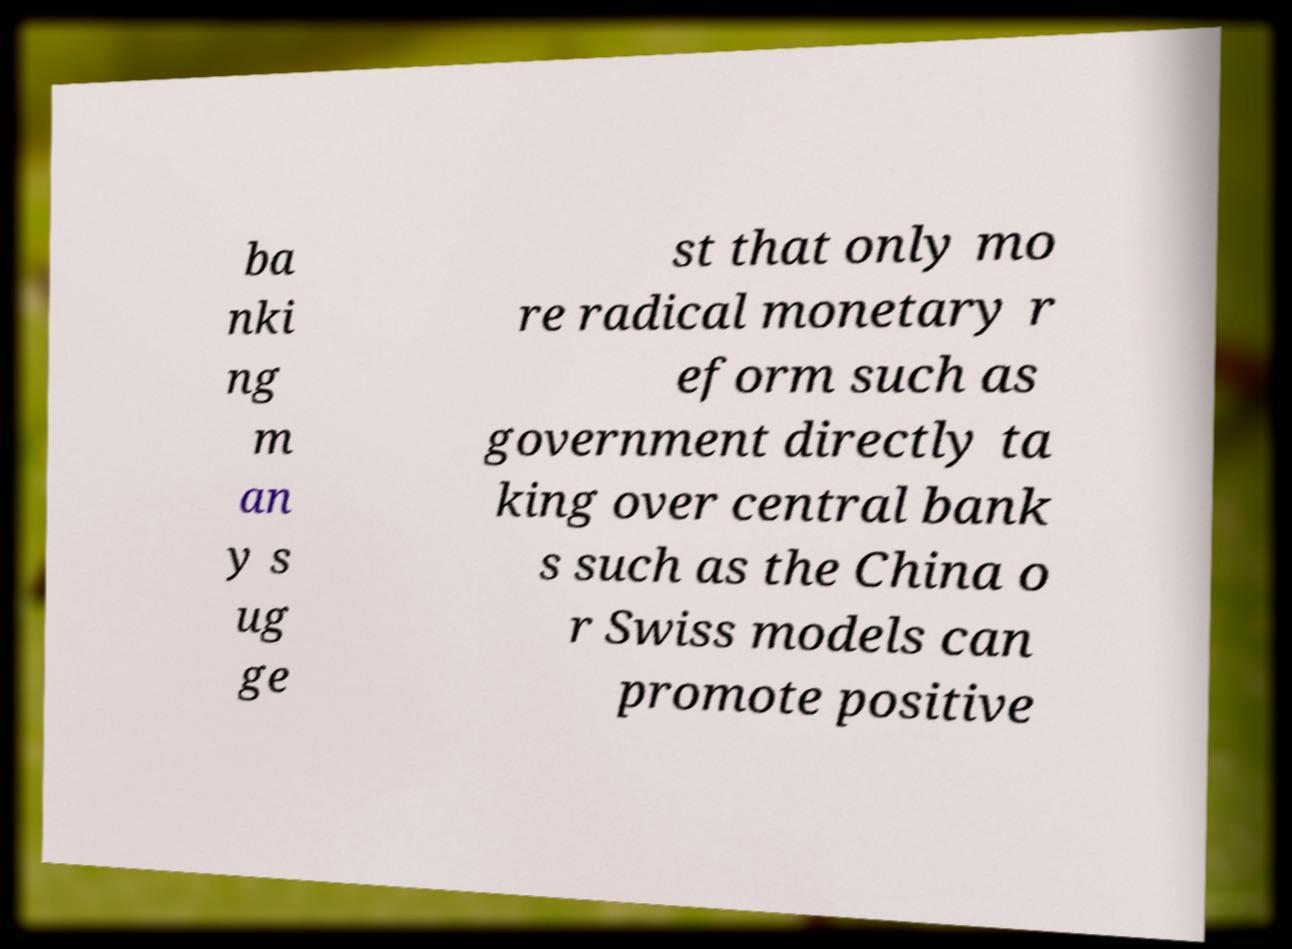Could you assist in decoding the text presented in this image and type it out clearly? ba nki ng m an y s ug ge st that only mo re radical monetary r eform such as government directly ta king over central bank s such as the China o r Swiss models can promote positive 